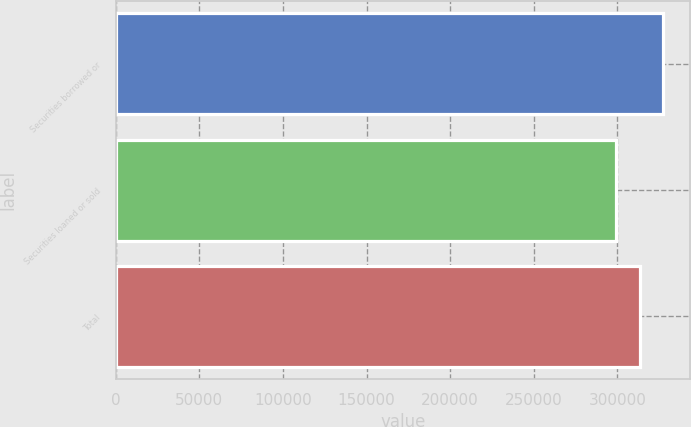<chart> <loc_0><loc_0><loc_500><loc_500><bar_chart><fcel>Securities borrowed or<fcel>Securities loaned or sold<fcel>Total<nl><fcel>326970<fcel>299028<fcel>313476<nl></chart> 